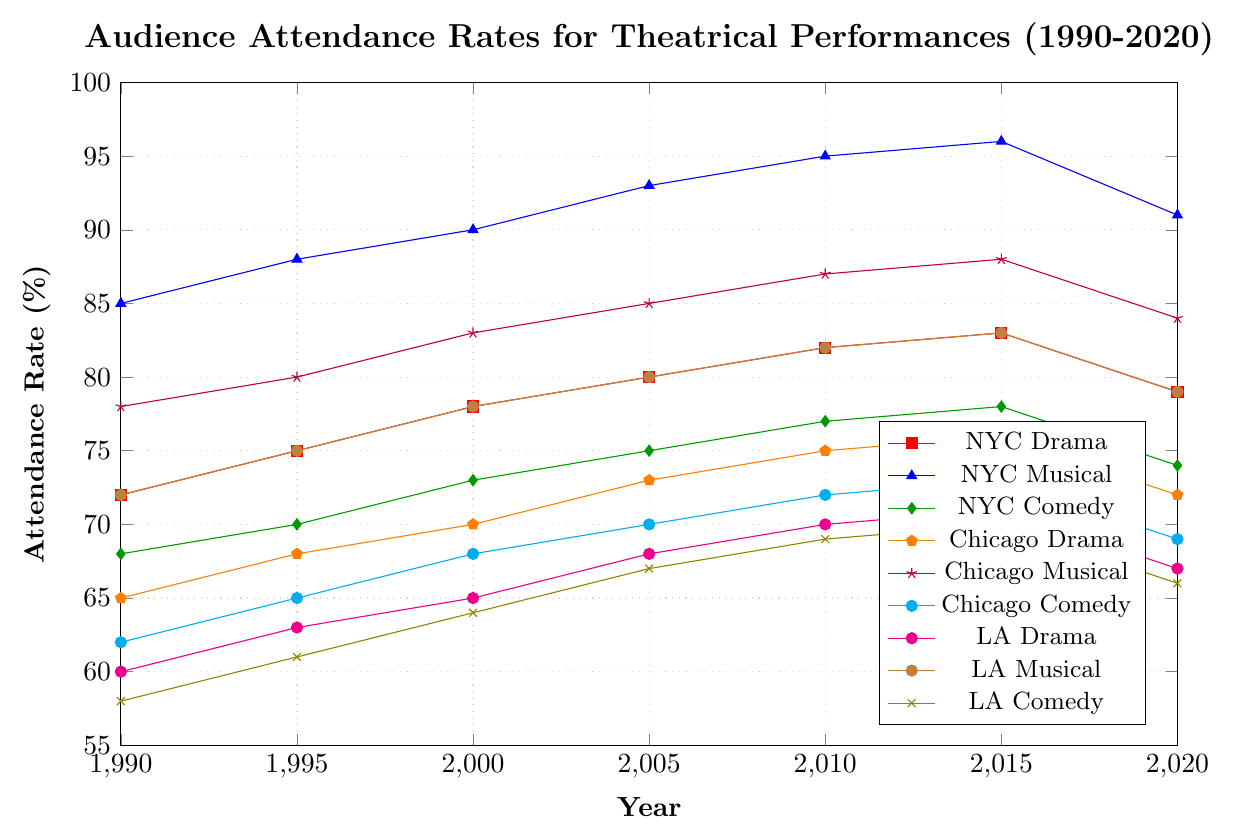what is the attendance rate for musicals in New York City in 2000? Locate the year 2000 on the x-axis and find the corresponding value for "NYC Musical", which is the second plot.
Answer: 90 Between 1990 and 2020, how did the attendance rates for Chicago Drama change? Track the "Chicago Drama" line from 1990 to 2020: starts at 65 in 1990, rises to a peak of 76 in 2015, then drops slightly to 72 by 2020.
Answer: Increased from 65 to 72 In 2010, which city's audience attendance rate for comedy was the highest? Compare the "Comedy" lines for all three cities at the year 2010: NYC (77), Chicago (72), LA (69).
Answer: New York City Which type of performance had the highest attendance rate in 2015 in Los Angeles? Look at 2015 on the x-axis and compare all three lines (Drama, Musical, Comedy) in Los Angeles: Drama (71), Musical (83), Comedy (70).
Answer: Musical What is the trend in attendance rates for musicals in Chicago from 1990 to 2020? Observe the "Chicago Musical" line: starts at 78 in 1990, rises steadily to a peak of 88 in 2015, then drops to 84 by 2020.
Answer: Increasing, then slight decrease How much higher was New York City Musical attendance in 2005 compared to Chicago Musical? Find the 2005 values for "NYC Musical" and "Chicago Musical": NYC (93), Chicago (85). The difference is 93 - 85.
Answer: 8 Did the attendance rates for dramas in Los Angeles and New York City ever equal? Compare the values for "NYC Drama" and "LA Drama" across all years, checking for any equal points. 1990: NYC (72), LA (60); 1995: NYC (75), LA (63); 2000: NYC (78), LA (65); 2005: NYC (80), LA (68); 2010: NYC (82), LA (70); 2015: NYC (83), LA (71); 2020: NYC (79), LA (67).
Answer: No Was there a year when attendance rates for dramas in all three cities were increasing? Analyze the trends for "Drama" in NYC, Chicago, and LA to find a common year of increase. NYC: 1990-2005 consistent increase, Chicago: 1990-2005 consistent increase, LA: 1990-2005 consistent increase.
Answer: 2005 